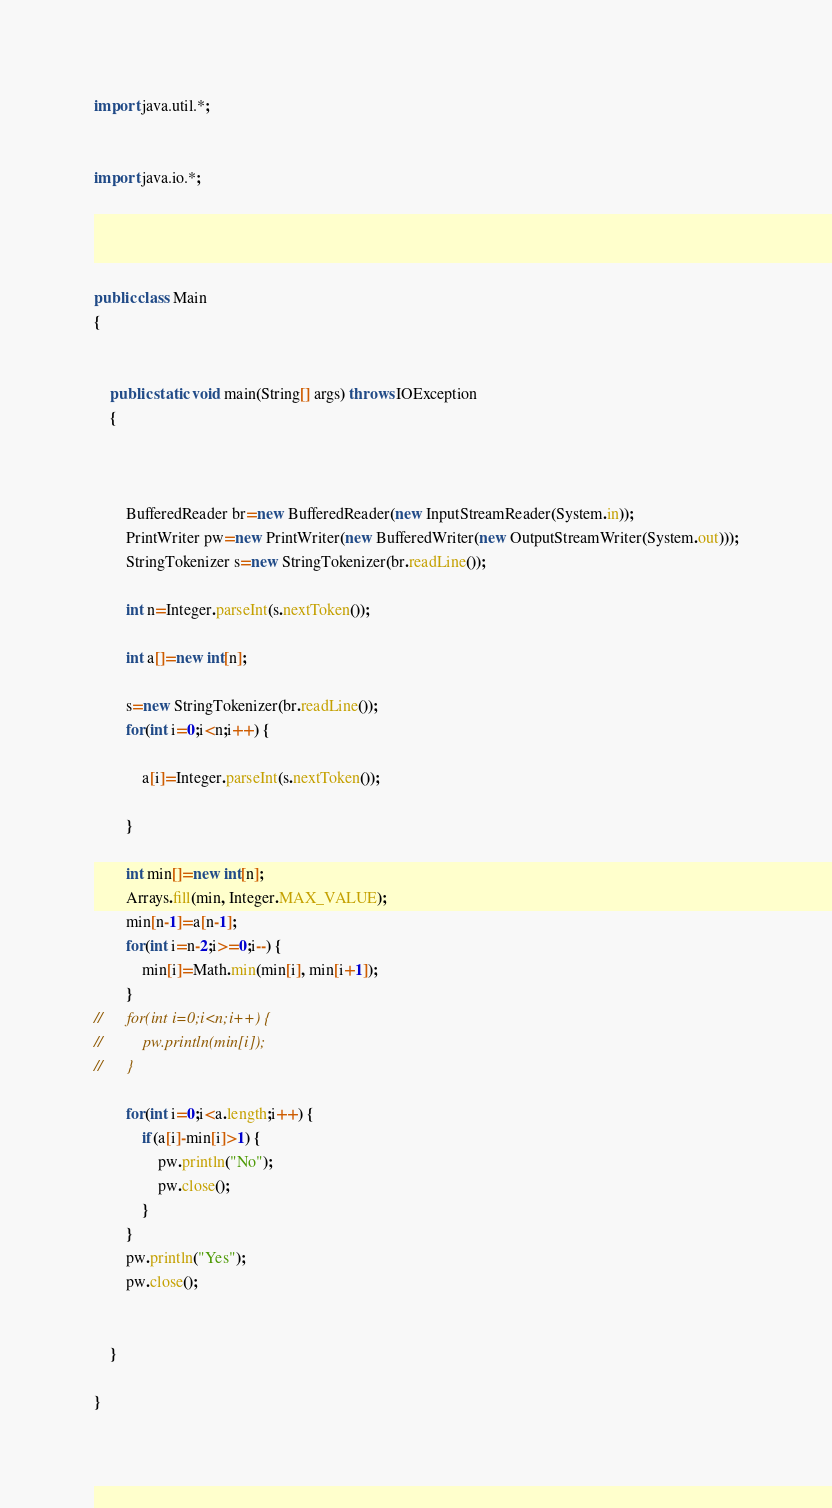<code> <loc_0><loc_0><loc_500><loc_500><_Java_>import java.util.*;


import java.io.*;
 

 
 
public class Main 
{   
	
	
	public static void main(String[] args) throws IOException 
	{ 
		
		
	
		BufferedReader br=new BufferedReader(new InputStreamReader(System.in));
		PrintWriter pw=new PrintWriter(new BufferedWriter(new OutputStreamWriter(System.out)));
		StringTokenizer s=new StringTokenizer(br.readLine());
		
		int n=Integer.parseInt(s.nextToken());
		
		int a[]=new int[n];
		
		s=new StringTokenizer(br.readLine());
		for(int i=0;i<n;i++) {
						
			a[i]=Integer.parseInt(s.nextToken());
			
		}
		
		int min[]=new int[n];
		Arrays.fill(min, Integer.MAX_VALUE);
		min[n-1]=a[n-1];
		for(int i=n-2;i>=0;i--) {
			min[i]=Math.min(min[i], min[i+1]);
		}
//		for(int i=0;i<n;i++) {
//			pw.println(min[i]);
//		}
		
		for(int i=0;i<a.length;i++) {
			if(a[i]-min[i]>1) {
				pw.println("No");
				pw.close();
			}
		}
		pw.println("Yes");
		pw.close();
		
		
	}

}</code> 